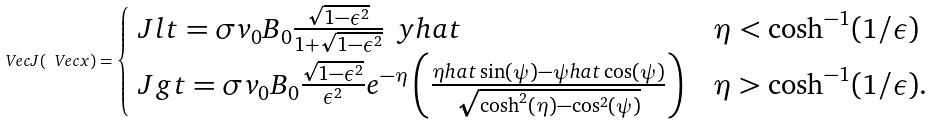<formula> <loc_0><loc_0><loc_500><loc_500>\ V e c { J } ( \ V e c { x } ) = \begin{cases} \ J l t = \sigma v _ { 0 } B _ { 0 } \frac { \sqrt { 1 - \epsilon ^ { 2 } } } { 1 + \sqrt { 1 - \epsilon ^ { 2 } } } \, \ y h a t & \eta < \cosh ^ { - 1 } ( 1 / \epsilon ) \\ \ J g t = \sigma v _ { 0 } B _ { 0 } \frac { \sqrt { 1 - \epsilon ^ { 2 } } } { \epsilon ^ { 2 } } e ^ { - \eta } \left ( \frac { \eta h a t \sin ( \psi ) - \psi h a t \cos ( \psi ) } { \sqrt { \cosh ^ { 2 } ( \eta ) - \cos ^ { 2 } ( \psi ) } } \right ) & \eta > \cosh ^ { - 1 } ( 1 / \epsilon ) . \end{cases}</formula> 